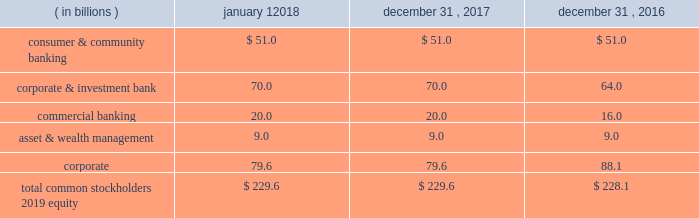Jpmorgan chase & co./2017 annual report 89 the table below reflects the firm 2019s assessed level of capital allocated to each line of business as of the dates indicated .
Line of business equity ( allocated capital ) .
Planning and stress testing comprehensive capital analysis and review the federal reserve requires large bank holding companies , including the firm , to submit a capital plan on an annual basis .
The federal reserve uses the ccar and dodd-frank act stress test processes to ensure that large bhcs have sufficient capital during periods of economic and financial stress , and have robust , forward-looking capital assessment and planning processes in place that address each bhc 2019s unique risks to enable it to absorb losses under certain stress scenarios .
Through the ccar , the federal reserve evaluates each bhc 2019s capital adequacy and internal capital adequacy assessment processes ( 201cicaap 201d ) , as well as its plans to make capital distributions , such as dividend payments or stock repurchases .
On june 28 , 2017 , the federal reserve informed the firm that it did not object , on either a quantitative or qualitative basis , to the firm 2019s 2017 capital plan .
For information on actions taken by the firm 2019s board of directors following the 2017 ccar results , see capital actions on pages 89-90 .
The firm 2019s ccar process is integrated into and employs the same methodologies utilized in the firm 2019s icaap process , as discussed below .
Internal capital adequacy assessment process semiannually , the firm completes the icaap , which provides management with a view of the impact of severe and unexpected events on earnings , balance sheet positions , reserves and capital .
The firm 2019s icaap integrates stress testing protocols with capital planning .
The process assesses the potential impact of alternative economic and business scenarios on the firm 2019s earnings and capital .
Economic scenarios , and the parameters underlying those scenarios , are defined centrally and applied uniformly across the businesses .
These scenarios are articulated in terms of macroeconomic factors , which are key drivers of business results ; global market shocks , which generate short-term but severe trading losses ; and idiosyncratic operational risk events .
The scenarios are intended to capture and stress key vulnerabilities and idiosyncratic risks facing the firm .
However , when defining a broad range of scenarios , actual events can always be worse .
Accordingly , management considers additional stresses outside these scenarios , as necessary .
Icaap results are reviewed by management and the audit committee .
Capital actions preferred stock preferred stock dividends declared were $ 1.7 billion for the year ended december 31 , 2017 .
On october 20 , 2017 , the firm issued $ 1.3 billion of fixed- to-floating rate non-cumulative preferred stock , series cc , with an initial dividend rate of 4.625% ( 4.625 % ) .
On december 1 , 2017 , the firm redeemed all $ 1.3 billion of its outstanding 5.50% ( 5.50 % ) non-cumulative preferred stock , series o .
For additional information on the firm 2019s preferred stock , see note 20 .
Trust preferred securities on december 18 , 2017 , the delaware trusts that issued seven series of outstanding trust preferred securities were liquidated , $ 1.6 billion of trust preferred and $ 56 million of common securities originally issued by those trusts were cancelled , and the junior subordinated debentures previously held by each trust issuer were distributed pro rata to the holders of the corresponding series of trust preferred and common securities .
The firm redeemed $ 1.6 billion of trust preferred securities in the year ended december 31 , 2016 .
Common stock dividends the firm 2019s common stock dividend policy reflects jpmorgan chase 2019s earnings outlook , desired dividend payout ratio , capital objectives , and alternative investment opportunities .
On september 19 , 2017 , the firm announced that its board of directors increased the quarterly common stock dividend to $ 0.56 per share , effective with the dividend paid on october 31 , 2017 .
The firm 2019s dividends are subject to the board of directors 2019 approval on a quarterly basis .
For information regarding dividend restrictions , see note 20 and note 25. .
In 2017 what was the percent of the corporate & investment bank as part of the total common stockholders 2019 equity allocated to each line of business? 
Computations: (70.0 / 229.6)
Answer: 0.30488. 